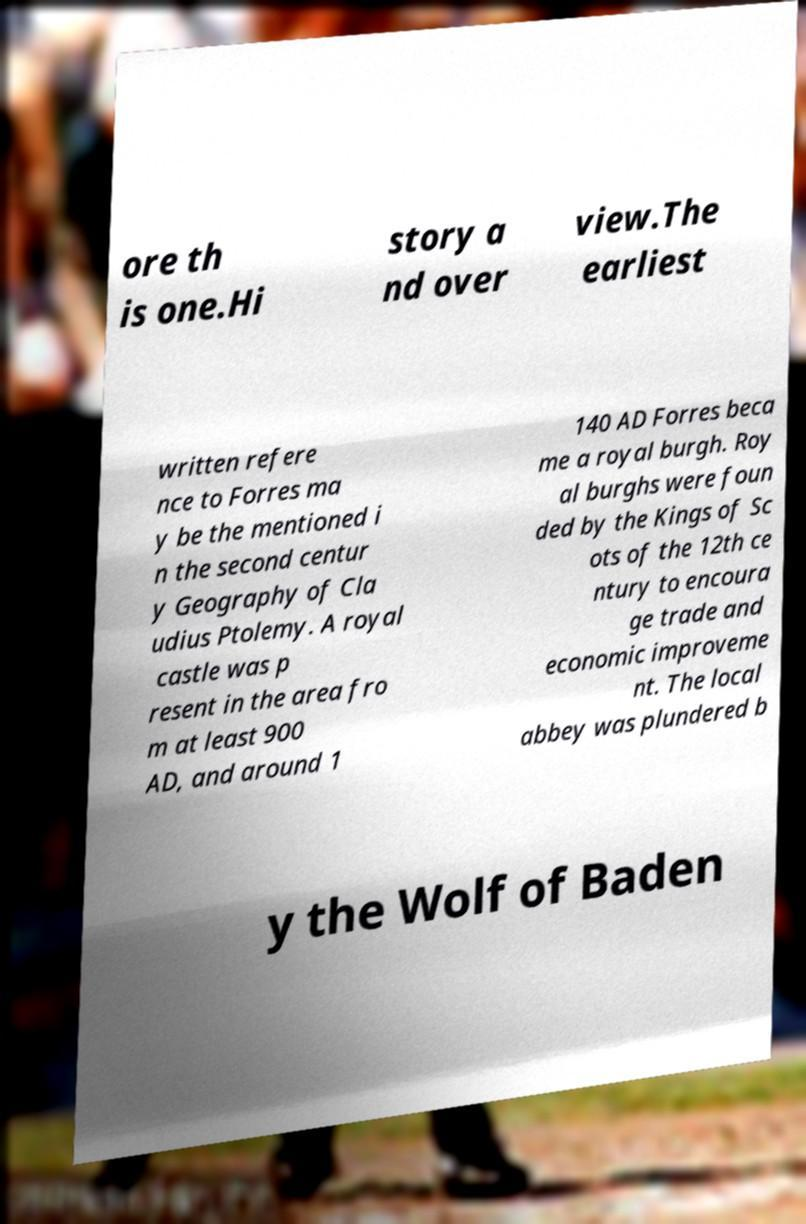Could you assist in decoding the text presented in this image and type it out clearly? ore th is one.Hi story a nd over view.The earliest written refere nce to Forres ma y be the mentioned i n the second centur y Geography of Cla udius Ptolemy. A royal castle was p resent in the area fro m at least 900 AD, and around 1 140 AD Forres beca me a royal burgh. Roy al burghs were foun ded by the Kings of Sc ots of the 12th ce ntury to encoura ge trade and economic improveme nt. The local abbey was plundered b y the Wolf of Baden 